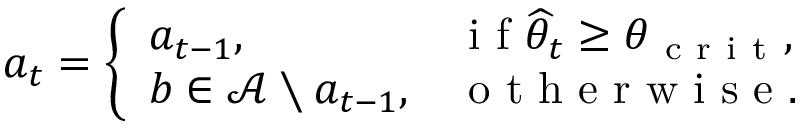Convert formula to latex. <formula><loc_0><loc_0><loc_500><loc_500>a _ { t } = \left \{ \begin{array} { l l } { a _ { t - 1 } , \quad } & { i f \widehat { \theta } _ { t } \geq \theta _ { c r i t } , } \\ { b \in \mathcal { A } \ a _ { t - 1 } , } & { o t h e r w i s e . } \end{array}</formula> 